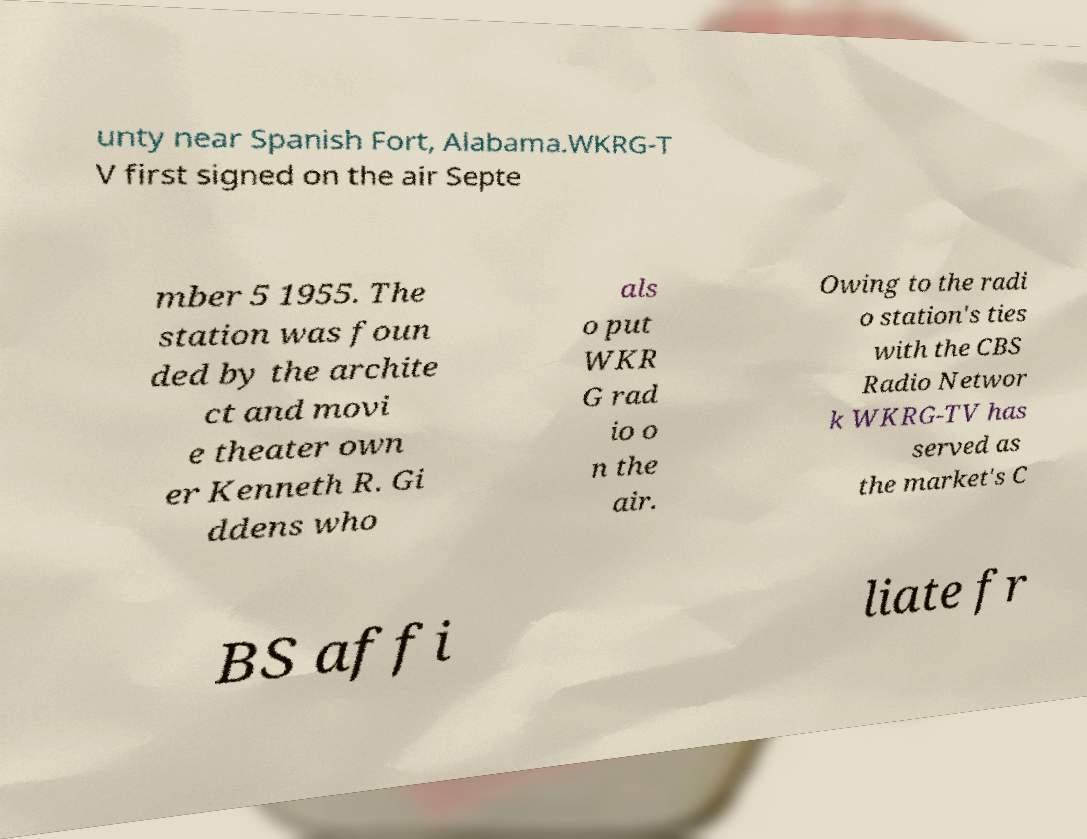For documentation purposes, I need the text within this image transcribed. Could you provide that? unty near Spanish Fort, Alabama.WKRG-T V first signed on the air Septe mber 5 1955. The station was foun ded by the archite ct and movi e theater own er Kenneth R. Gi ddens who als o put WKR G rad io o n the air. Owing to the radi o station's ties with the CBS Radio Networ k WKRG-TV has served as the market's C BS affi liate fr 